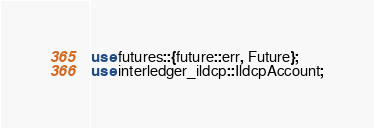<code> <loc_0><loc_0><loc_500><loc_500><_Rust_>use futures::{future::err, Future};
use interledger_ildcp::IldcpAccount;</code> 